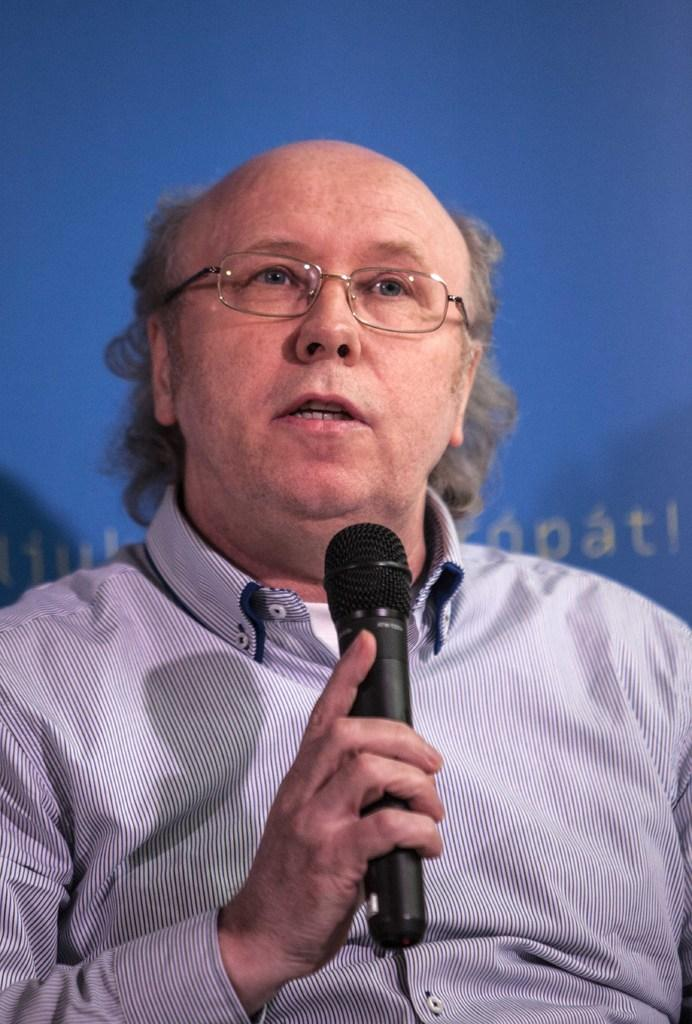What is the man in the image doing? The man is talking on a microphone. Can you describe the man's appearance in the image? The man is wearing spectacles. What can be seen in the background of the image? There is a banner in the background of the image. What type of mist can be seen surrounding the man in the image? There is no mist present in the image; it is a clear scene with the man talking on a microphone and wearing spectacles, with a banner in the background. 